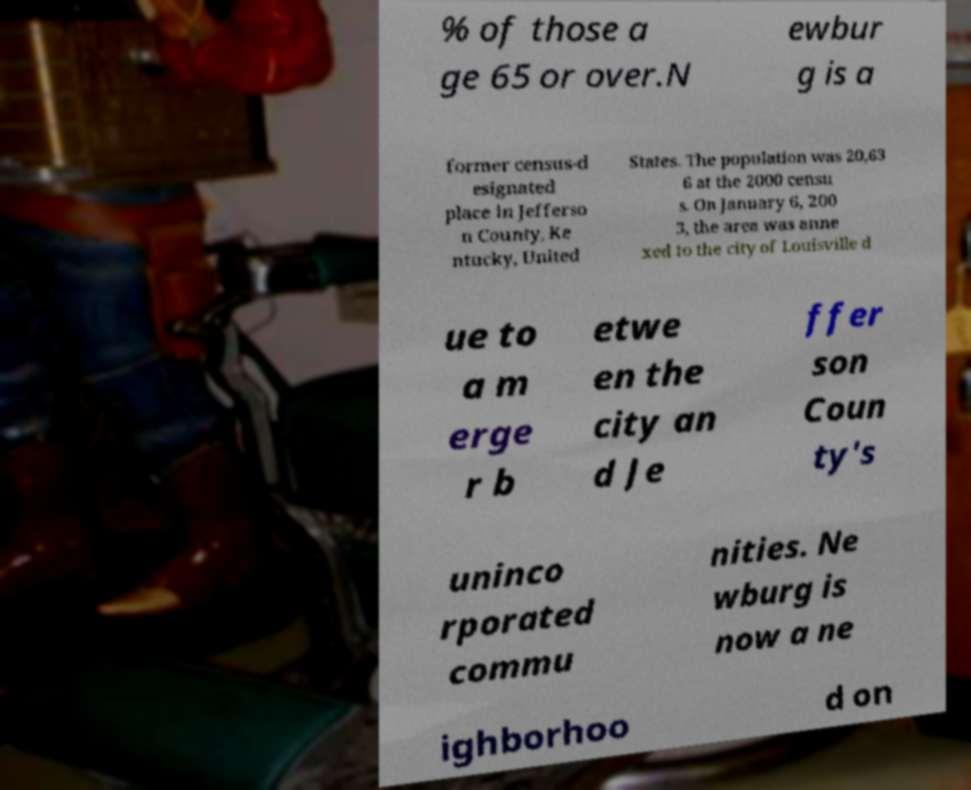What messages or text are displayed in this image? I need them in a readable, typed format. % of those a ge 65 or over.N ewbur g is a former census-d esignated place in Jefferso n County, Ke ntucky, United States. The population was 20,63 6 at the 2000 censu s. On January 6, 200 3, the area was anne xed to the city of Louisville d ue to a m erge r b etwe en the city an d Je ffer son Coun ty's uninco rporated commu nities. Ne wburg is now a ne ighborhoo d on 